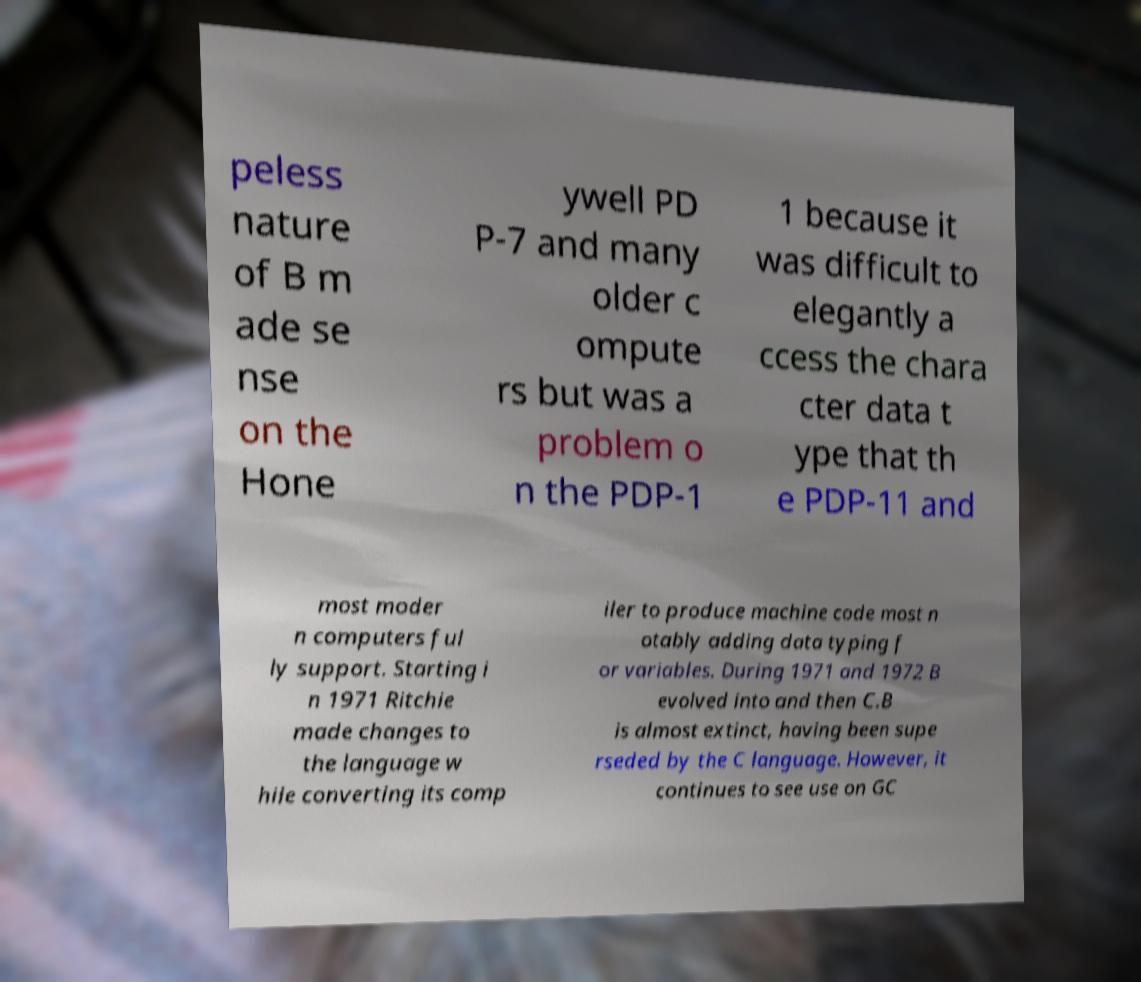I need the written content from this picture converted into text. Can you do that? peless nature of B m ade se nse on the Hone ywell PD P-7 and many older c ompute rs but was a problem o n the PDP-1 1 because it was difficult to elegantly a ccess the chara cter data t ype that th e PDP-11 and most moder n computers ful ly support. Starting i n 1971 Ritchie made changes to the language w hile converting its comp iler to produce machine code most n otably adding data typing f or variables. During 1971 and 1972 B evolved into and then C.B is almost extinct, having been supe rseded by the C language. However, it continues to see use on GC 